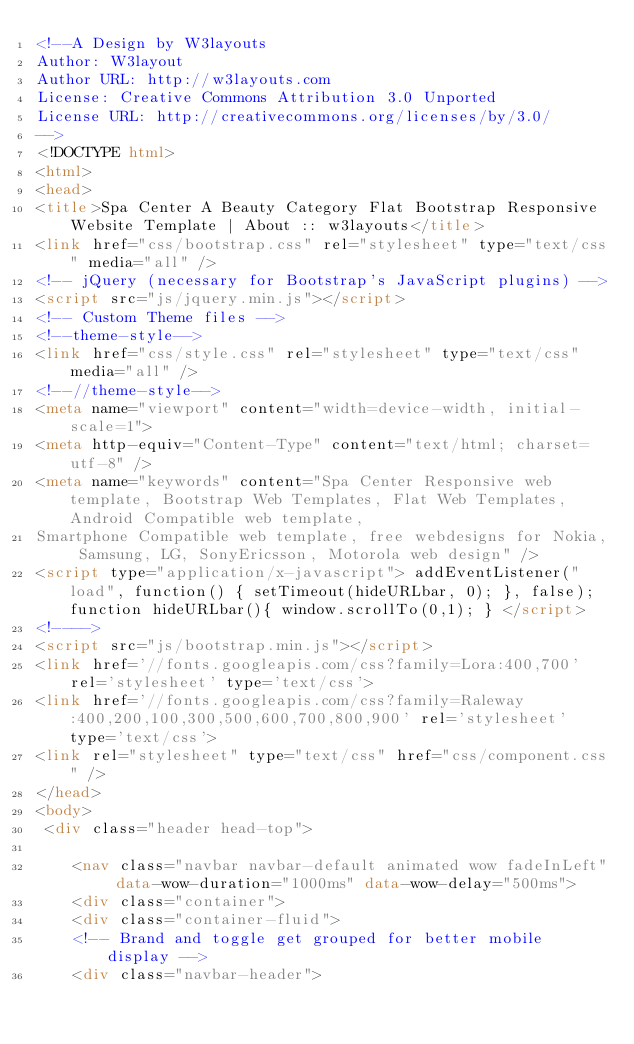<code> <loc_0><loc_0><loc_500><loc_500><_HTML_><!--A Design by W3layouts 
Author: W3layout
Author URL: http://w3layouts.com
License: Creative Commons Attribution 3.0 Unported
License URL: http://creativecommons.org/licenses/by/3.0/
-->
<!DOCTYPE html>
<html>
<head>
<title>Spa Center A Beauty Category Flat Bootstrap Responsive Website Template | About :: w3layouts</title>
<link href="css/bootstrap.css" rel="stylesheet" type="text/css" media="all" />
<!-- jQuery (necessary for Bootstrap's JavaScript plugins) -->
<script src="js/jquery.min.js"></script>
<!-- Custom Theme files -->
<!--theme-style-->
<link href="css/style.css" rel="stylesheet" type="text/css" media="all" />	
<!--//theme-style-->
<meta name="viewport" content="width=device-width, initial-scale=1">
<meta http-equiv="Content-Type" content="text/html; charset=utf-8" />
<meta name="keywords" content="Spa Center Responsive web template, Bootstrap Web Templates, Flat Web Templates, Android Compatible web template, 
Smartphone Compatible web template, free webdesigns for Nokia, Samsung, LG, SonyEricsson, Motorola web design" />
<script type="application/x-javascript"> addEventListener("load", function() { setTimeout(hideURLbar, 0); }, false); function hideURLbar(){ window.scrollTo(0,1); } </script>
<!---->
<script src="js/bootstrap.min.js"></script>
<link href='//fonts.googleapis.com/css?family=Lora:400,700' rel='stylesheet' type='text/css'>
<link href='//fonts.googleapis.com/css?family=Raleway:400,200,100,300,500,600,700,800,900' rel='stylesheet' type='text/css'>
<link rel="stylesheet" type="text/css" href="css/component.css" />
</head>
<body>
 <div class="header head-top">
	
		<nav class="navbar navbar-default animated wow fadeInLeft" data-wow-duration="1000ms" data-wow-delay="500ms">
		<div class="container">
	  <div class="container-fluid">
		<!-- Brand and toggle get grouped for better mobile display -->
		<div class="navbar-header"></code> 